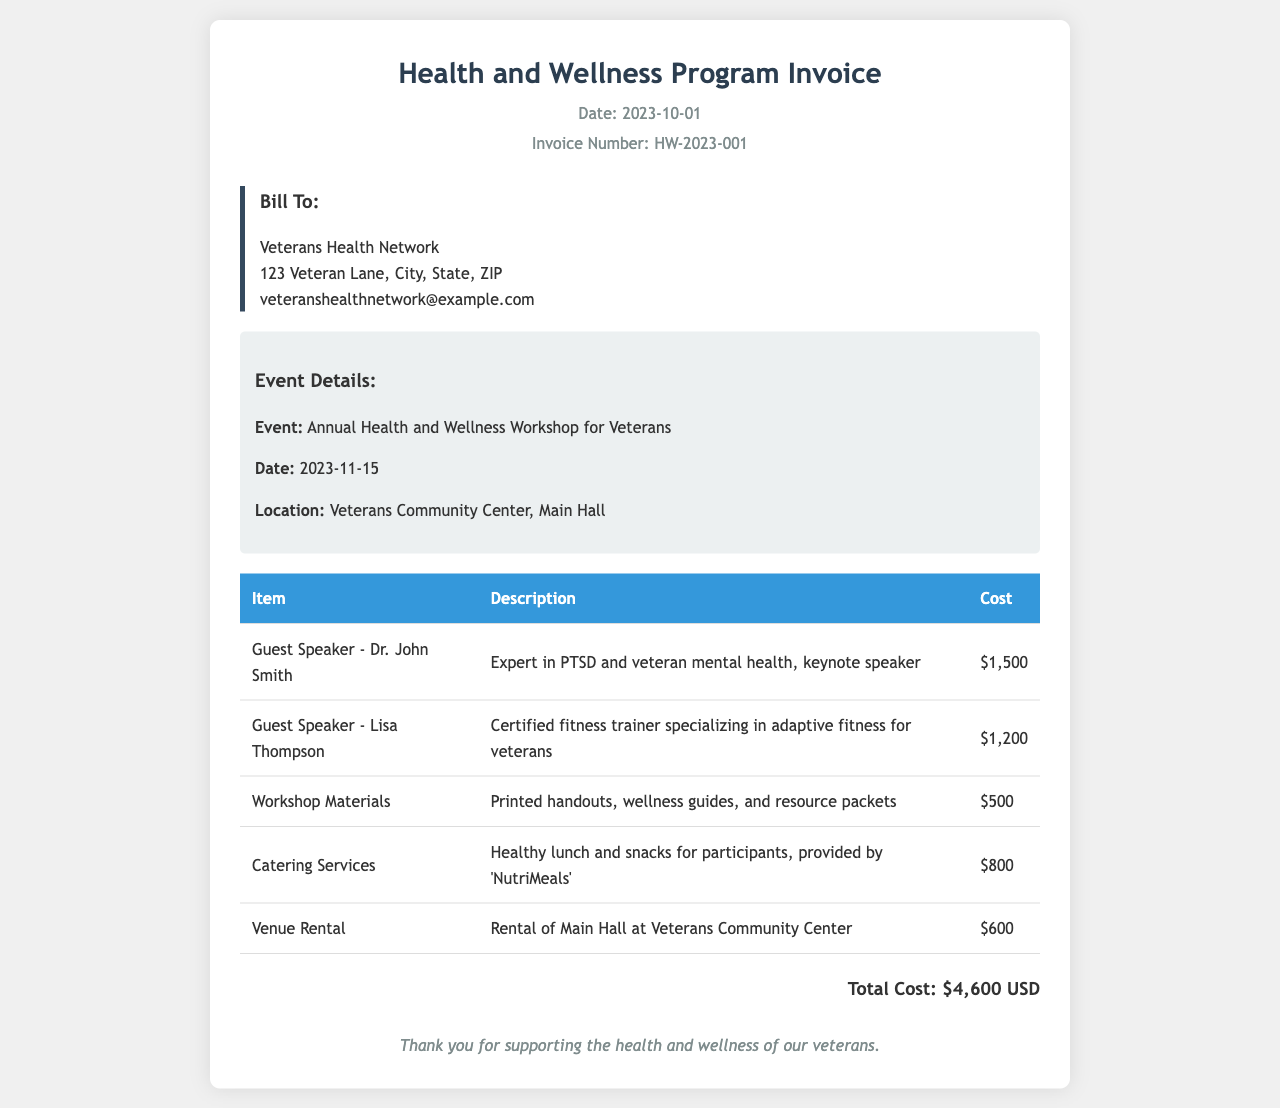what is the date of the event? The event date is mentioned in the event details section of the document.
Answer: 2023-11-15 who is the keynote speaker? The document lists Dr. John Smith as the keynote speaker in the itemized section.
Answer: Dr. John Smith what is the cost of catering services? The cost for catering services is specified in the table of costs.
Answer: $800 how many guest speakers are listed? By counting the entries in the itemized section, we can determine the number of guest speakers.
Answer: 2 what is the total cost for the workshop? The total workshop cost is summarized at the end of the invoice.
Answer: $4,600 USD what kind of venue is rented? The venue type is stated clearly in the itemized section regarding venue rental.
Answer: Main Hall why is Lisa Thompson noted in the document? Lisa Thompson is mentioned as a guest speaker with a specific expertise related to veterans.
Answer: Certified fitness trainer what material is provided for the workshop? The document specifies the types of materials included as part of the workshop offerings.
Answer: Printed handouts, wellness guides, and resource packets what is the invoice number? The invoice number can be found in the header of the document.
Answer: HW-2023-001 